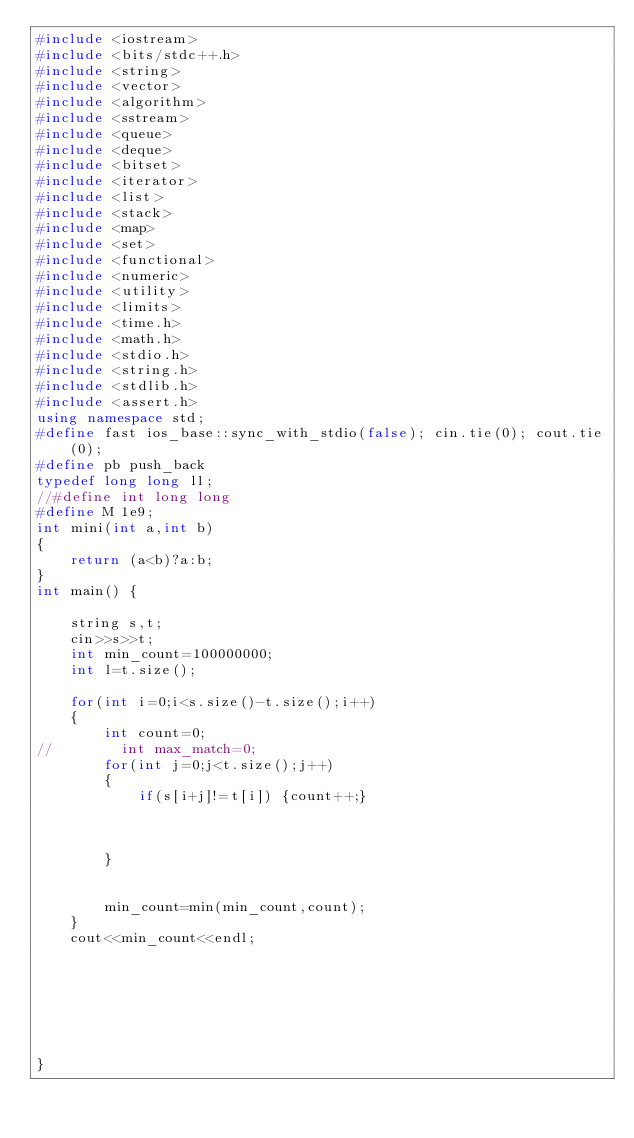<code> <loc_0><loc_0><loc_500><loc_500><_C++_>#include <iostream>
#include <bits/stdc++.h>
#include <string>
#include <vector>
#include <algorithm>
#include <sstream>
#include <queue>
#include <deque>
#include <bitset>
#include <iterator>
#include <list>
#include <stack>
#include <map>
#include <set>
#include <functional>
#include <numeric>
#include <utility>
#include <limits>
#include <time.h>
#include <math.h>
#include <stdio.h>
#include <string.h>
#include <stdlib.h>
#include <assert.h>
using namespace std;
#define fast ios_base::sync_with_stdio(false); cin.tie(0); cout.tie(0);
#define pb push_back
typedef long long ll;
//#define int long long
#define M 1e9;
int mini(int a,int b)
{
    return (a<b)?a:b;
}
int main() {

    string s,t;
    cin>>s>>t;
    int min_count=100000000;
    int l=t.size();

    for(int i=0;i<s.size()-t.size();i++)
    {
        int count=0;
//        int max_match=0;
        for(int j=0;j<t.size();j++)
        {
            if(s[i+j]!=t[i]) {count++;}



        }


        min_count=min(min_count,count);
    }
    cout<<min_count<<endl;







}
</code> 